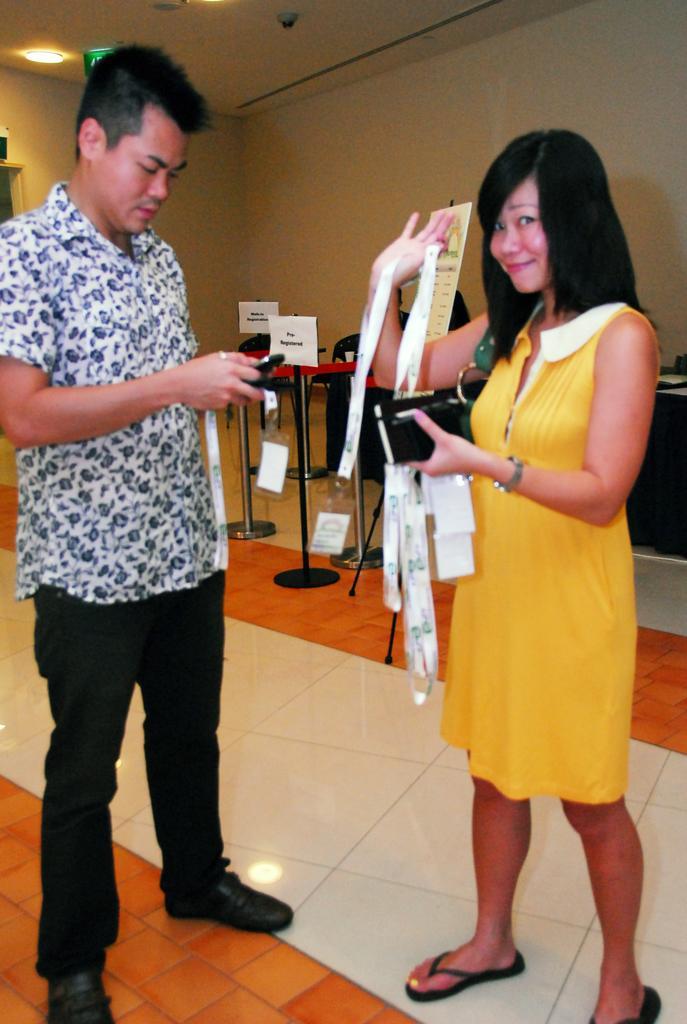Please provide a concise description of this image. In this image we can see a man and a man standing on the floor. Of them man is holding mobile phone and a paper in his hands and woman is holding labels and a wallet in her hands. In the background there are barrier poles, name boards, chairs, tables, electric lights to the roof and walls. 